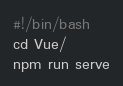Convert code to text. <code><loc_0><loc_0><loc_500><loc_500><_Bash_>#!/bin/bash
cd Vue/
npm run serve
</code> 